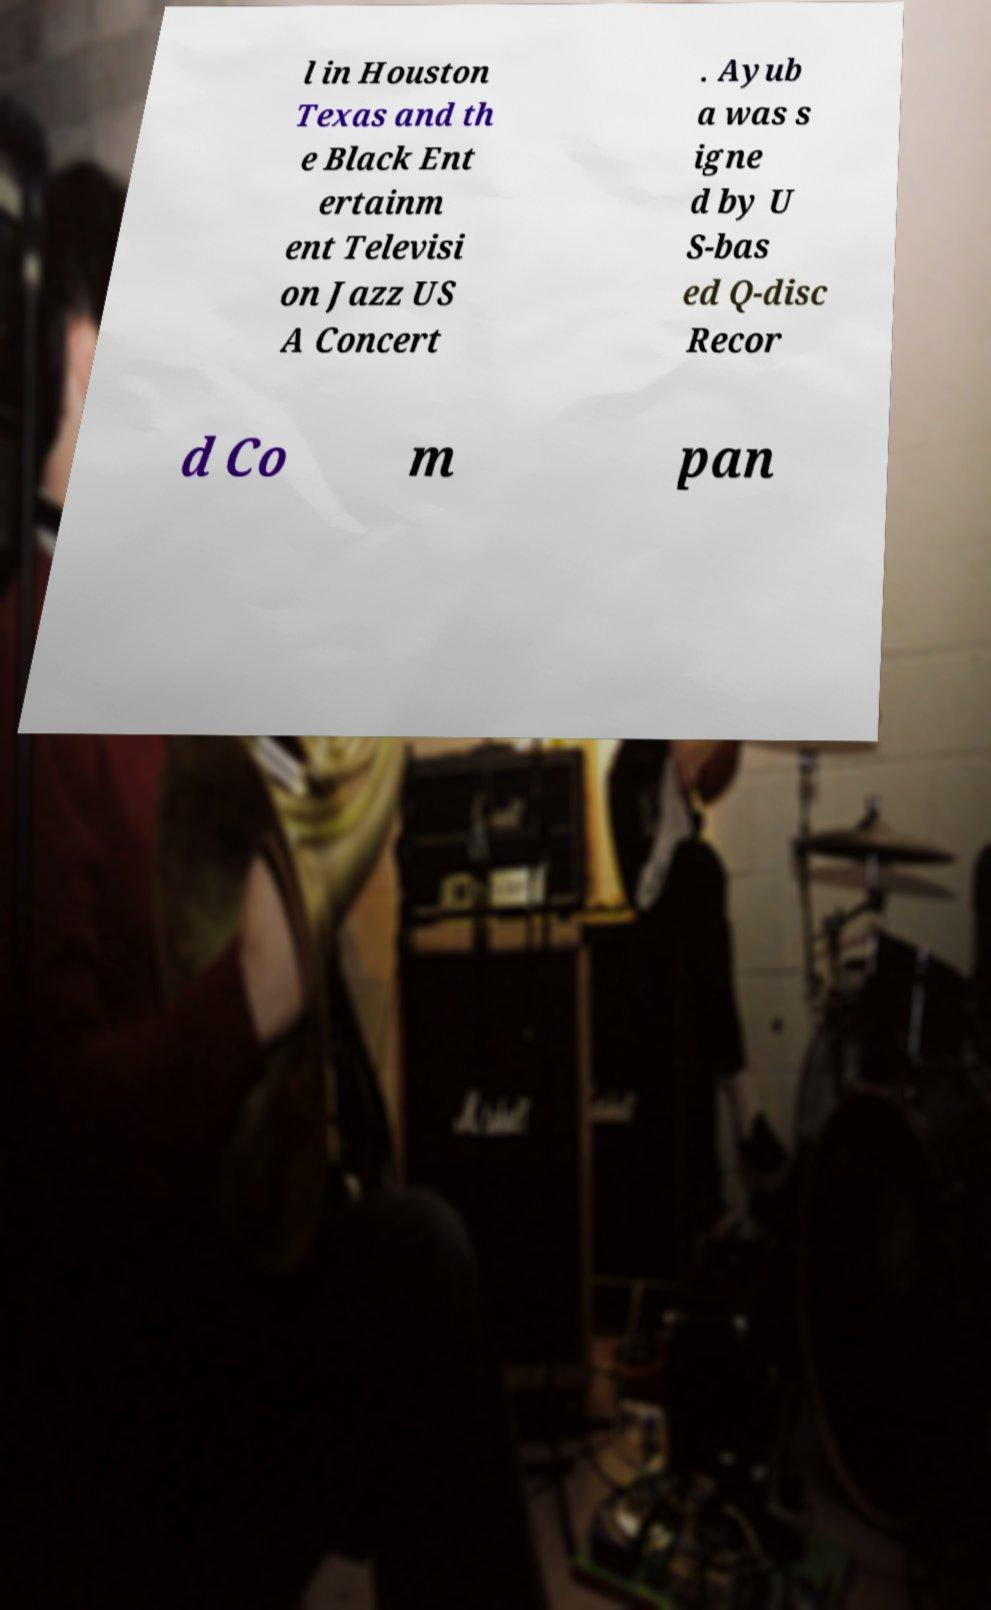I need the written content from this picture converted into text. Can you do that? l in Houston Texas and th e Black Ent ertainm ent Televisi on Jazz US A Concert . Ayub a was s igne d by U S-bas ed Q-disc Recor d Co m pan 